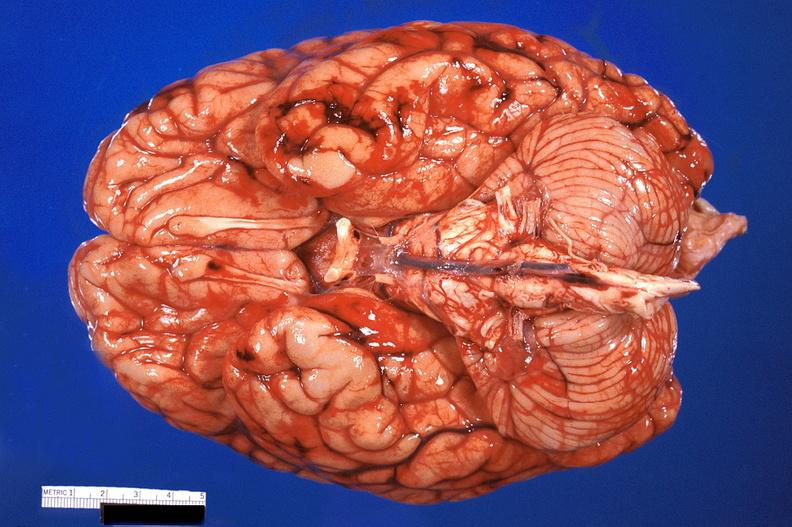s meningioma in posterior fossa present?
Answer the question using a single word or phrase. No 